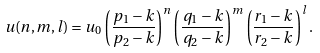Convert formula to latex. <formula><loc_0><loc_0><loc_500><loc_500>u ( n , m , l ) = u _ { 0 } \left ( \frac { p _ { 1 } - k } { p _ { 2 } - k } \right ) ^ { n } \left ( \frac { q _ { 1 } - k } { q _ { 2 } - k } \right ) ^ { m } \left ( \frac { r _ { 1 } - k } { r _ { 2 } - k } \right ) ^ { l } .</formula> 